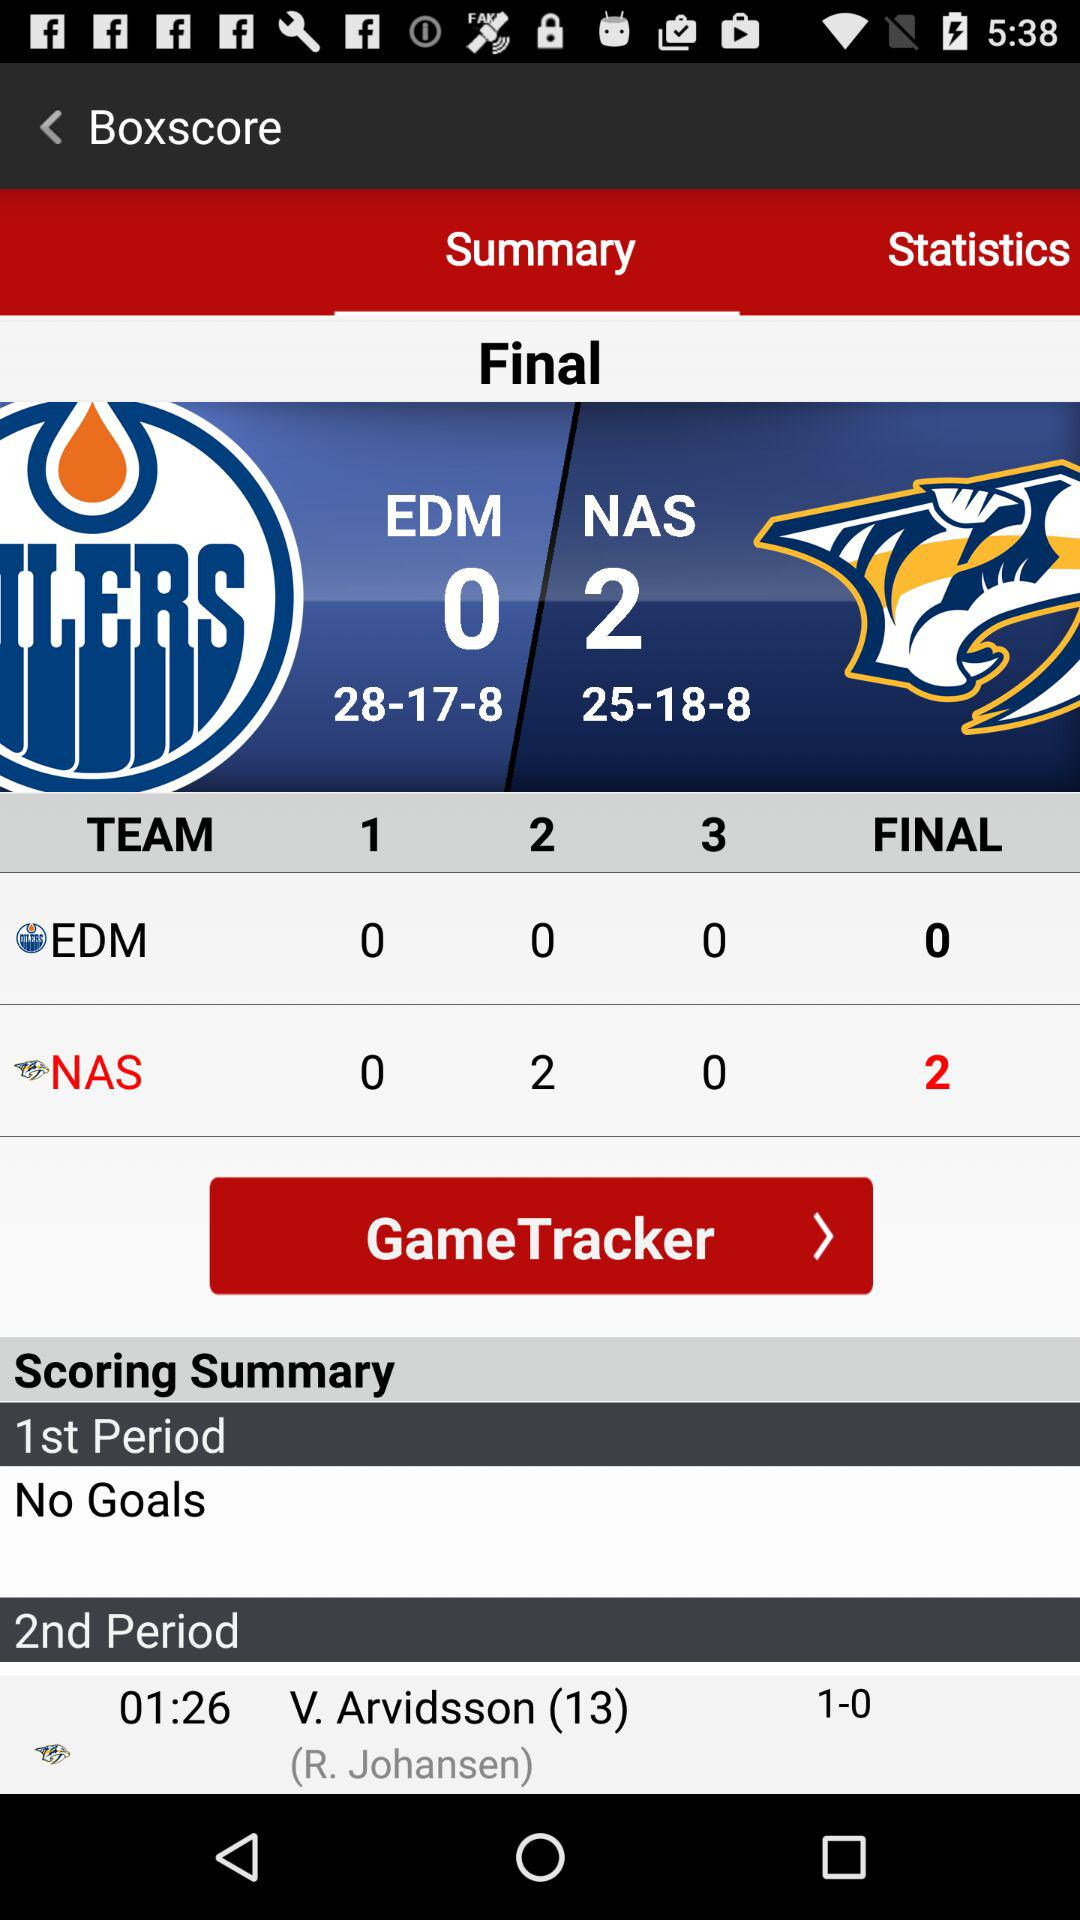What is the name of the teams that are playing? The names of the teams are EDM and NAS. 